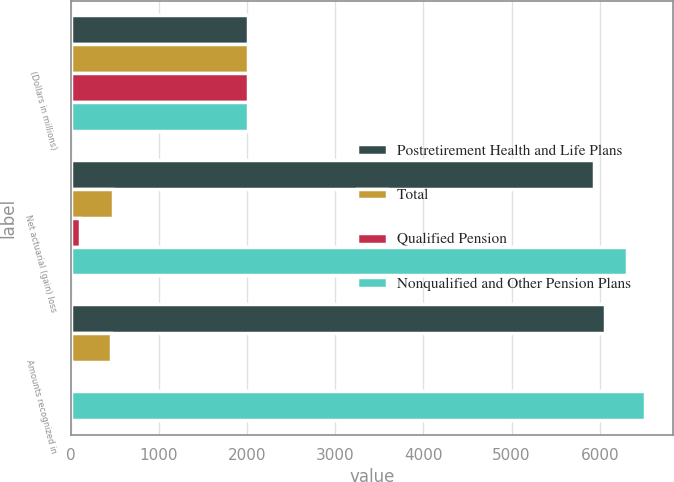Convert chart. <chart><loc_0><loc_0><loc_500><loc_500><stacked_bar_chart><ecel><fcel>(Dollars in millions)<fcel>Net actuarial (gain) loss<fcel>Amounts recognized in<nl><fcel>Postretirement Health and Life Plans<fcel>2009<fcel>5937<fcel>6063<nl><fcel>Total<fcel>2009<fcel>479<fcel>457<nl><fcel>Qualified Pension<fcel>2009<fcel>106<fcel>11<nl><fcel>Nonqualified and Other Pension Plans<fcel>2009<fcel>6310<fcel>6509<nl></chart> 